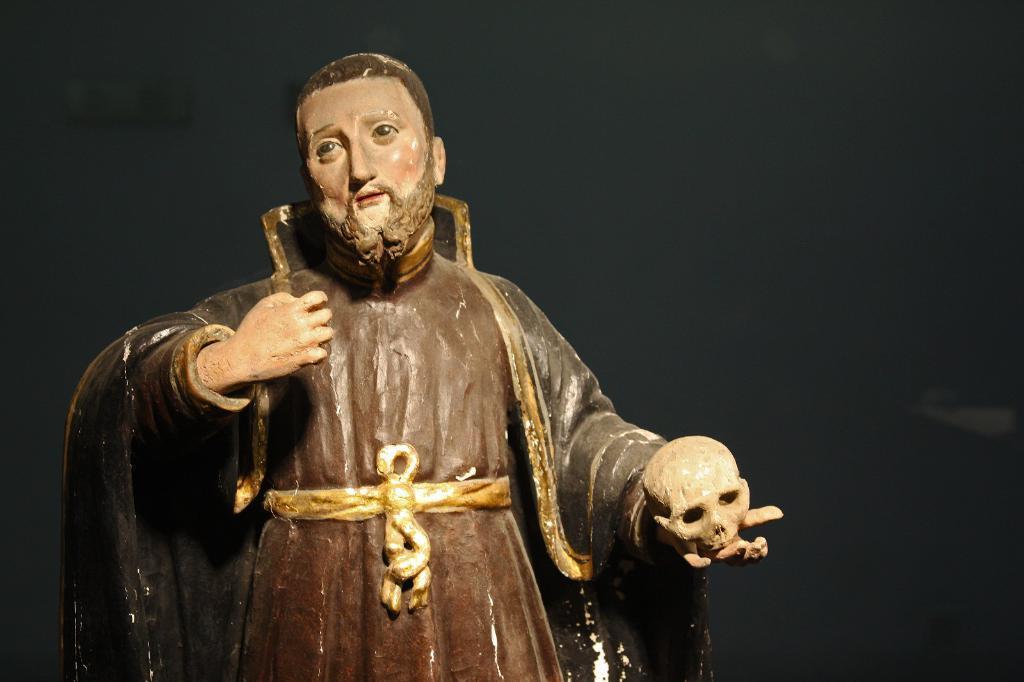Please provide a concise description of this image. In this image, we can see a human sculpture. 